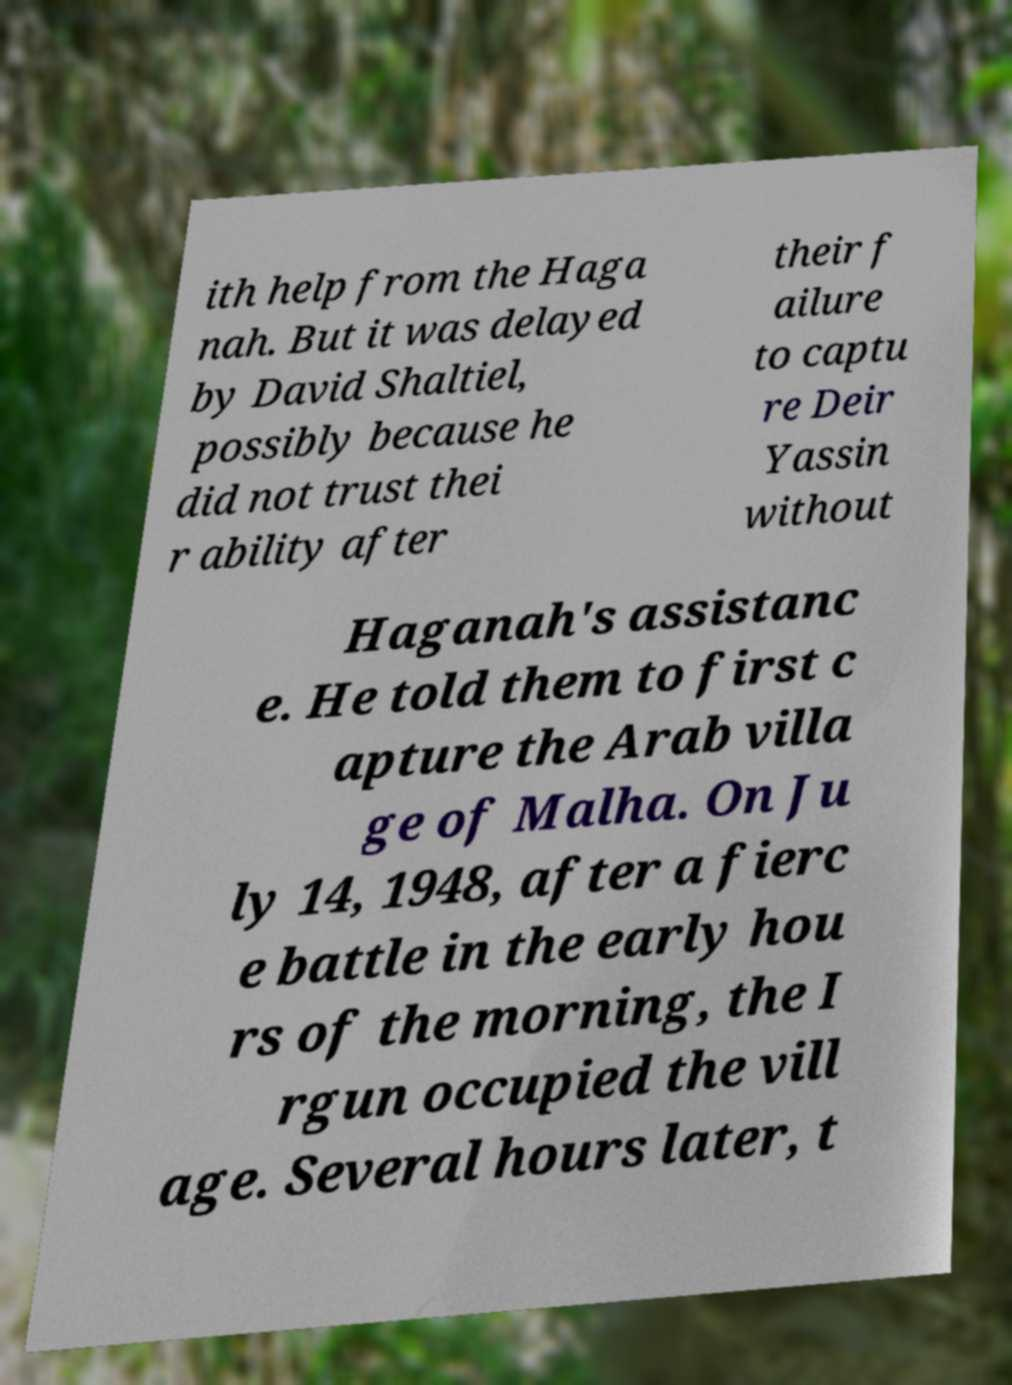Can you accurately transcribe the text from the provided image for me? ith help from the Haga nah. But it was delayed by David Shaltiel, possibly because he did not trust thei r ability after their f ailure to captu re Deir Yassin without Haganah's assistanc e. He told them to first c apture the Arab villa ge of Malha. On Ju ly 14, 1948, after a fierc e battle in the early hou rs of the morning, the I rgun occupied the vill age. Several hours later, t 